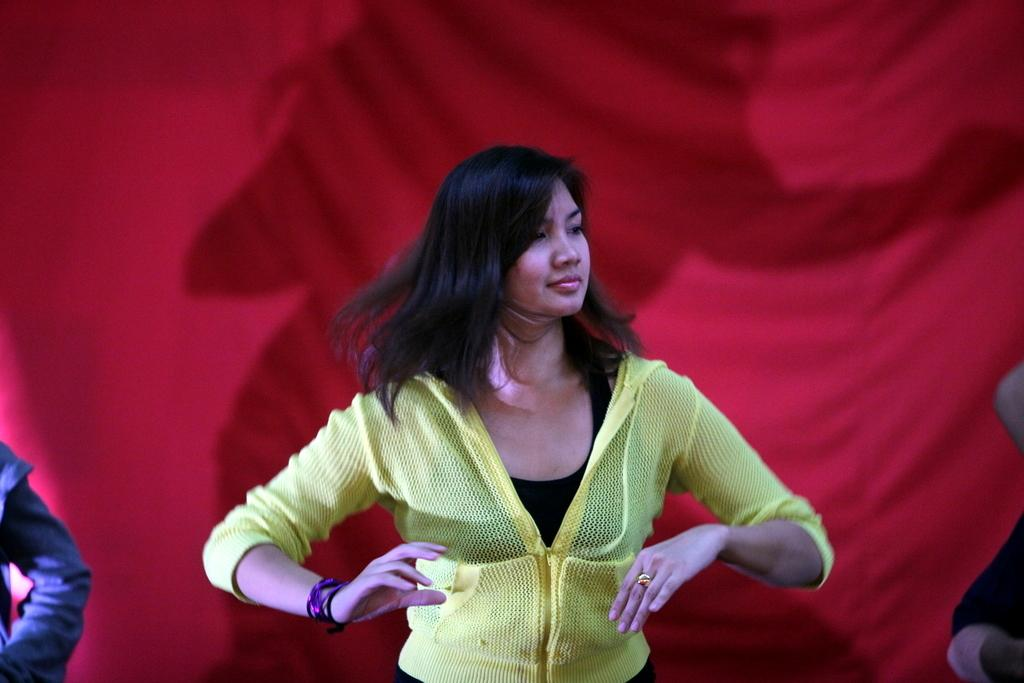Who is present in the image? There is a woman in the image. What can be seen in the background or surrounding the woman? There is a curtain visible in the image. What type of mark can be seen on the curtain in the image? There is no mark visible on the curtain in the image. What kind of machine is present in the image? There is no machine present in the image; it only features a woman and a curtain. 